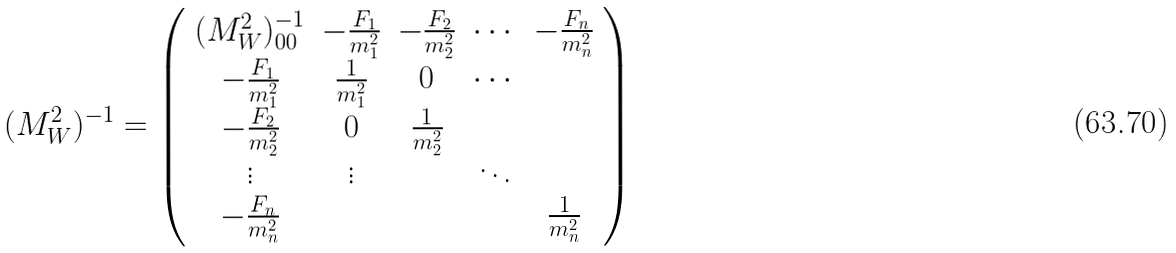<formula> <loc_0><loc_0><loc_500><loc_500>( M _ { W } ^ { 2 } ) ^ { - 1 } = \left ( \begin{array} { c c c c c } ( M _ { W } ^ { 2 } ) ^ { - 1 } _ { 0 0 } & - \frac { F _ { 1 } } { m _ { 1 } ^ { 2 } } & - \frac { F _ { 2 } } { m _ { 2 } ^ { 2 } } & \cdots & - \frac { F _ { n } } { m _ { n } ^ { 2 } } \\ - \frac { F _ { 1 } } { m _ { 1 } ^ { 2 } } & \frac { 1 } { m _ { 1 } ^ { 2 } } & 0 & \cdots & \\ - \frac { F _ { 2 } } { m _ { 2 } ^ { 2 } } & 0 & \frac { 1 } { m _ { 2 } ^ { 2 } } & & \\ \vdots & \vdots & & \ddots & \\ - \frac { F _ { n } } { m _ { n } ^ { 2 } } & & & & \frac { 1 } { m _ { n } ^ { 2 } } \end{array} \right )</formula> 